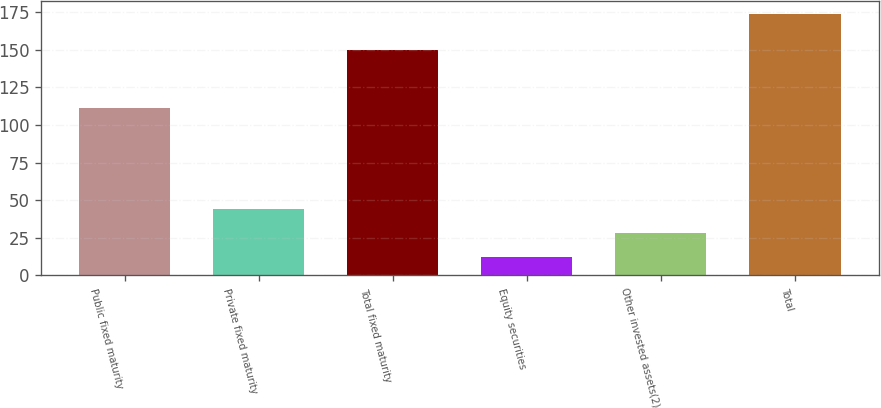Convert chart to OTSL. <chart><loc_0><loc_0><loc_500><loc_500><bar_chart><fcel>Public fixed maturity<fcel>Private fixed maturity<fcel>Total fixed maturity<fcel>Equity securities<fcel>Other invested assets(2)<fcel>Total<nl><fcel>111<fcel>44.4<fcel>150<fcel>12<fcel>28.2<fcel>174<nl></chart> 